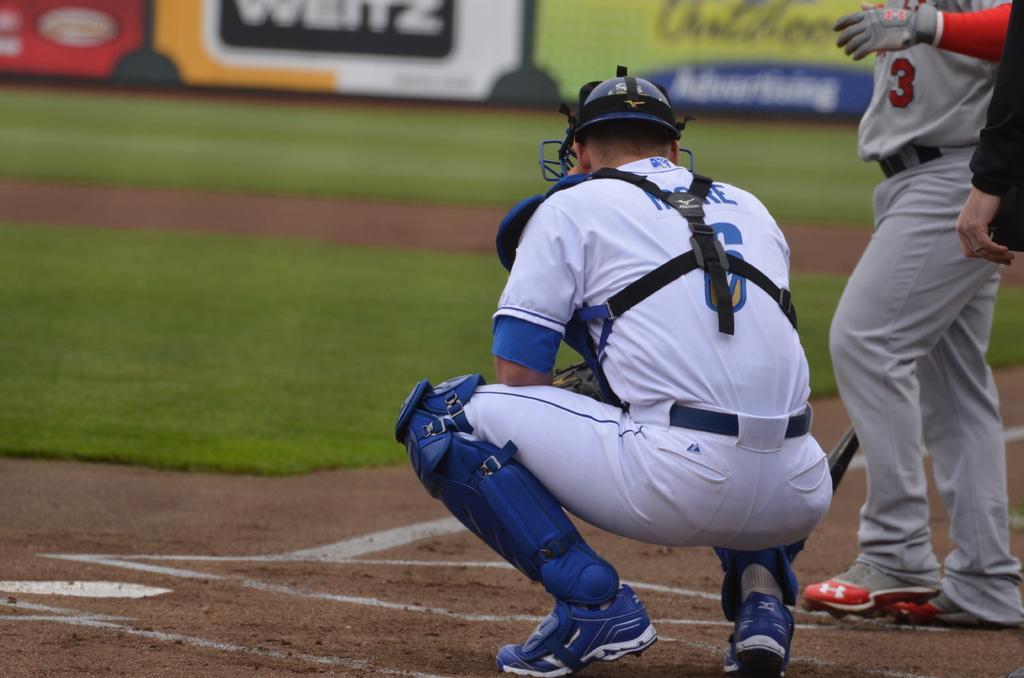In one or two sentences, can you explain what this image depicts? In the center of the image we can see players on the ground. In the background we can see grass and fencing. 